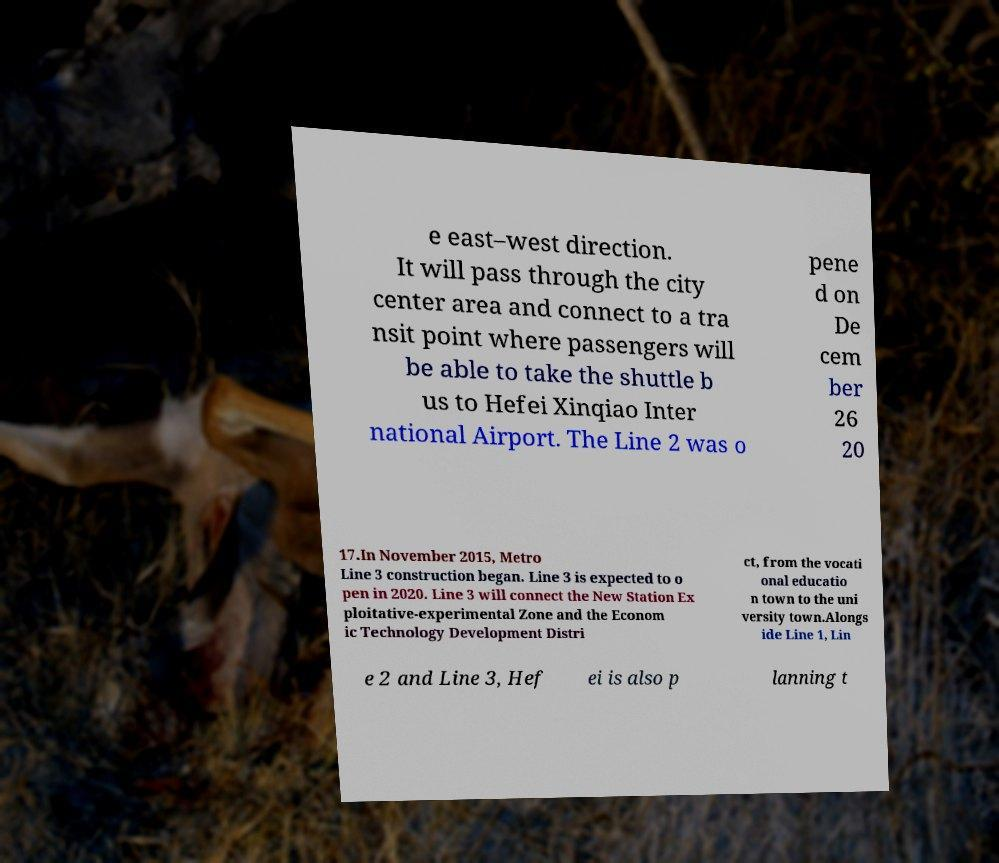There's text embedded in this image that I need extracted. Can you transcribe it verbatim? e east–west direction. It will pass through the city center area and connect to a tra nsit point where passengers will be able to take the shuttle b us to Hefei Xinqiao Inter national Airport. The Line 2 was o pene d on De cem ber 26 20 17.In November 2015, Metro Line 3 construction began. Line 3 is expected to o pen in 2020. Line 3 will connect the New Station Ex ploitative-experimental Zone and the Econom ic Technology Development Distri ct, from the vocati onal educatio n town to the uni versity town.Alongs ide Line 1, Lin e 2 and Line 3, Hef ei is also p lanning t 